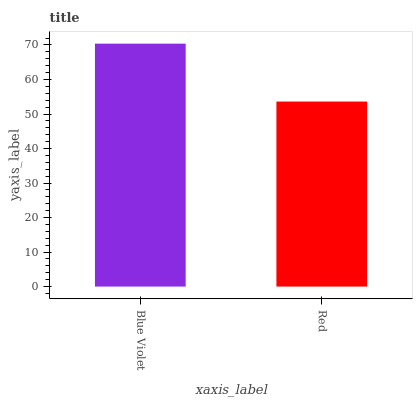Is Red the minimum?
Answer yes or no. Yes. Is Blue Violet the maximum?
Answer yes or no. Yes. Is Red the maximum?
Answer yes or no. No. Is Blue Violet greater than Red?
Answer yes or no. Yes. Is Red less than Blue Violet?
Answer yes or no. Yes. Is Red greater than Blue Violet?
Answer yes or no. No. Is Blue Violet less than Red?
Answer yes or no. No. Is Blue Violet the high median?
Answer yes or no. Yes. Is Red the low median?
Answer yes or no. Yes. Is Red the high median?
Answer yes or no. No. Is Blue Violet the low median?
Answer yes or no. No. 